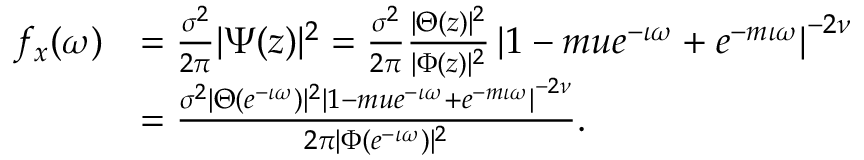Convert formula to latex. <formula><loc_0><loc_0><loc_500><loc_500>\begin{array} { r l } { f _ { x } ( \omega ) } & { = \frac { \sigma ^ { 2 } } { 2 \pi } | \Psi ( z ) | ^ { 2 } = \frac { \sigma ^ { 2 } } { 2 \pi } \frac { | \Theta ( z ) | ^ { 2 } } { | \Phi ( z ) | ^ { 2 } } \left | 1 - m u e ^ { - \iota \omega } + e ^ { - m \iota \omega } \right | ^ { - 2 \nu } } \\ & { = \frac { \sigma ^ { 2 } | \Theta ( e ^ { - \iota \omega } ) | ^ { 2 } \left | 1 - m u e ^ { - \iota \omega } + e ^ { - m \iota \omega } \right | ^ { - 2 \nu } } { 2 \pi | \Phi ( e ^ { - \iota \omega } ) | ^ { 2 } } . } \end{array}</formula> 